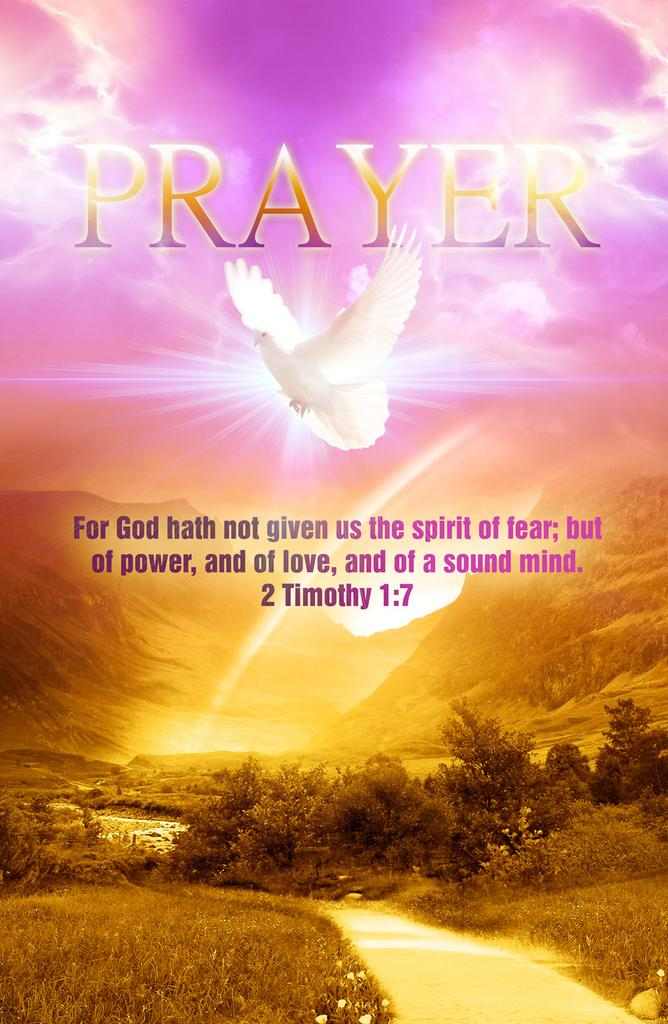Provide a one-sentence caption for the provided image. A dove flying on top of the mountain as a symbol that god hath not given us the spirit of fear but  of power. 